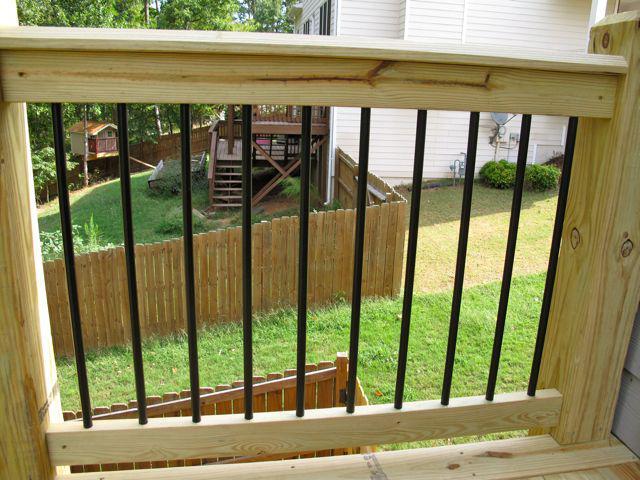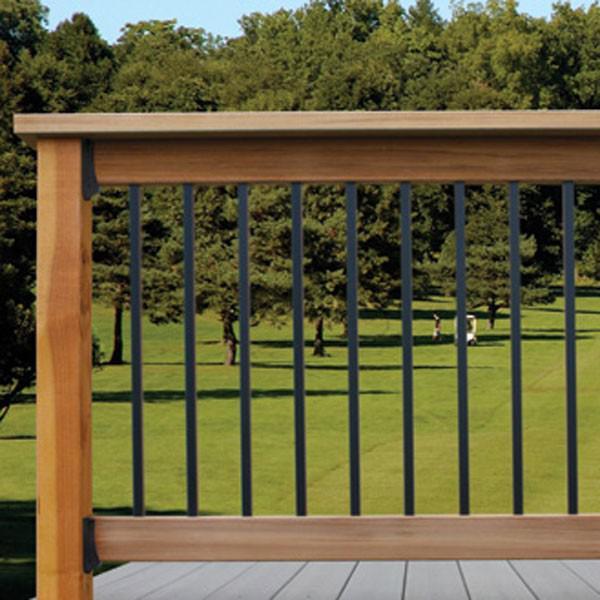The first image is the image on the left, the second image is the image on the right. Examine the images to the left and right. Is the description "There are railings made of wood in each image" accurate? Answer yes or no. Yes. The first image is the image on the left, the second image is the image on the right. Considering the images on both sides, is "One image shows an all-black metal gate with hinges on the left and the latch on the right." valid? Answer yes or no. No. 